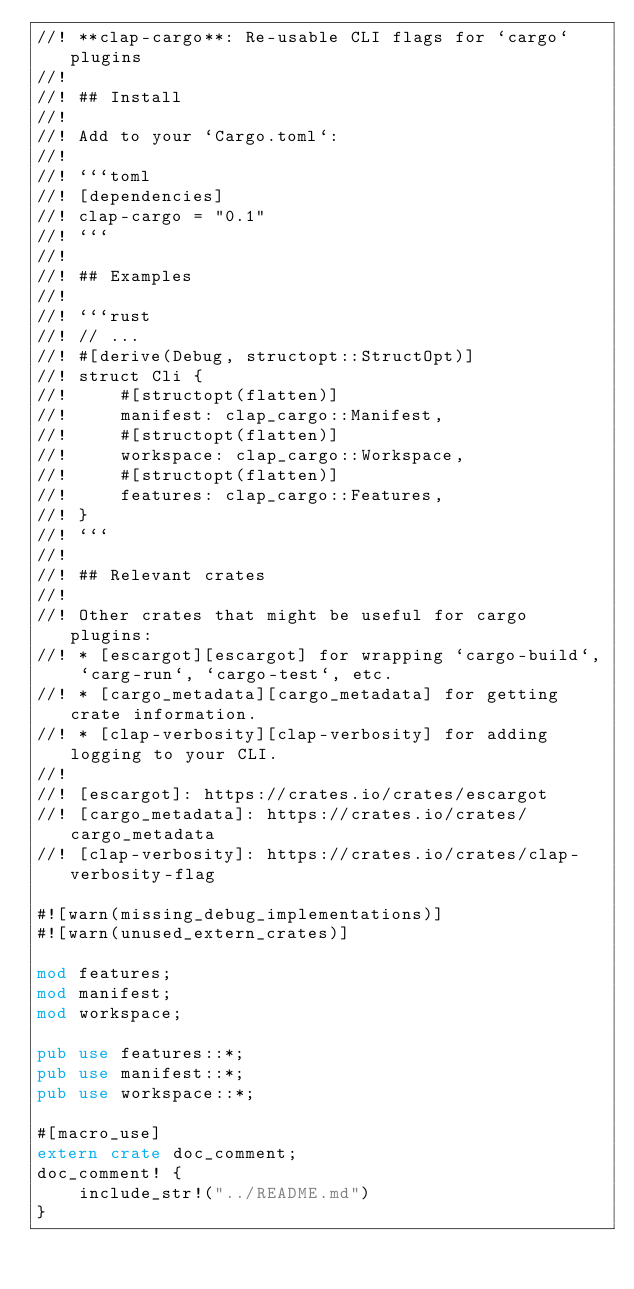Convert code to text. <code><loc_0><loc_0><loc_500><loc_500><_Rust_>//! **clap-cargo**: Re-usable CLI flags for `cargo` plugins
//!
//! ## Install
//!
//! Add to your `Cargo.toml`:
//!
//! ```toml
//! [dependencies]
//! clap-cargo = "0.1"
//! ```
//!
//! ## Examples
//!
//! ```rust
//! // ...
//! #[derive(Debug, structopt::StructOpt)]
//! struct Cli {
//!     #[structopt(flatten)]
//!     manifest: clap_cargo::Manifest,
//!     #[structopt(flatten)]
//!     workspace: clap_cargo::Workspace,
//!     #[structopt(flatten)]
//!     features: clap_cargo::Features,
//! }
//! ```
//!
//! ## Relevant crates
//!
//! Other crates that might be useful for cargo plugins:
//! * [escargot][escargot] for wrapping `cargo-build`, `carg-run`, `cargo-test`, etc.
//! * [cargo_metadata][cargo_metadata] for getting crate information.
//! * [clap-verbosity][clap-verbosity] for adding logging to your CLI.
//!
//! [escargot]: https://crates.io/crates/escargot
//! [cargo_metadata]: https://crates.io/crates/cargo_metadata
//! [clap-verbosity]: https://crates.io/crates/clap-verbosity-flag

#![warn(missing_debug_implementations)]
#![warn(unused_extern_crates)]

mod features;
mod manifest;
mod workspace;

pub use features::*;
pub use manifest::*;
pub use workspace::*;

#[macro_use]
extern crate doc_comment;
doc_comment! {
    include_str!("../README.md")
}
</code> 